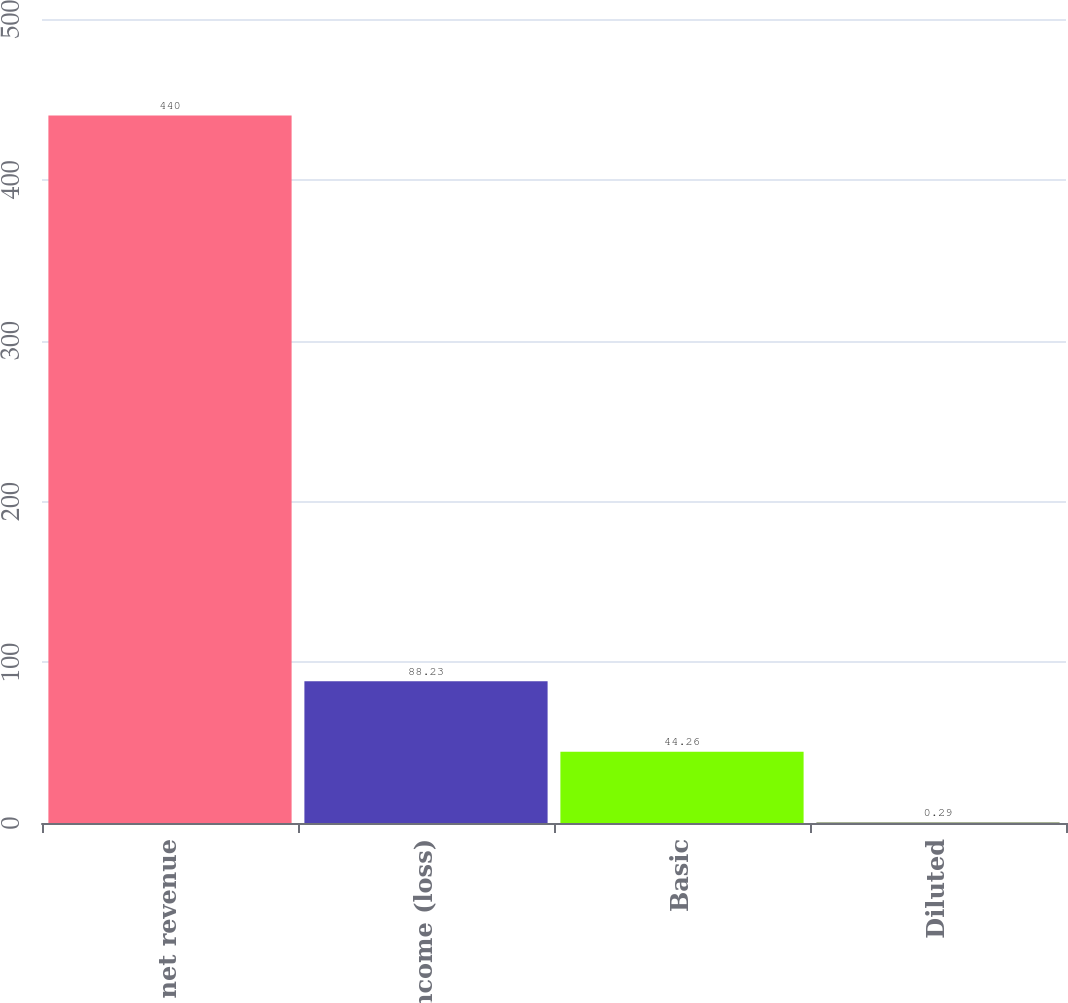Convert chart. <chart><loc_0><loc_0><loc_500><loc_500><bar_chart><fcel>Total net revenue<fcel>Net income (loss)<fcel>Basic<fcel>Diluted<nl><fcel>440<fcel>88.23<fcel>44.26<fcel>0.29<nl></chart> 